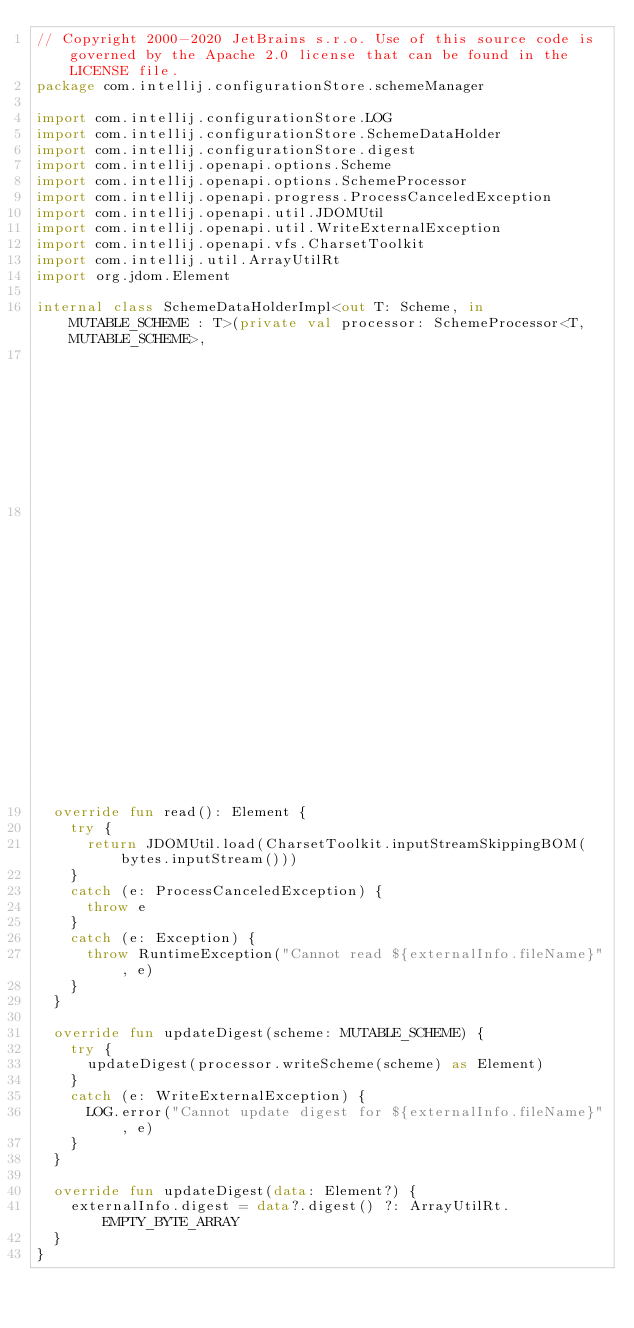Convert code to text. <code><loc_0><loc_0><loc_500><loc_500><_Kotlin_>// Copyright 2000-2020 JetBrains s.r.o. Use of this source code is governed by the Apache 2.0 license that can be found in the LICENSE file.
package com.intellij.configurationStore.schemeManager

import com.intellij.configurationStore.LOG
import com.intellij.configurationStore.SchemeDataHolder
import com.intellij.configurationStore.digest
import com.intellij.openapi.options.Scheme
import com.intellij.openapi.options.SchemeProcessor
import com.intellij.openapi.progress.ProcessCanceledException
import com.intellij.openapi.util.JDOMUtil
import com.intellij.openapi.util.WriteExternalException
import com.intellij.openapi.vfs.CharsetToolkit
import com.intellij.util.ArrayUtilRt
import org.jdom.Element

internal class SchemeDataHolderImpl<out T: Scheme, in MUTABLE_SCHEME : T>(private val processor: SchemeProcessor<T, MUTABLE_SCHEME>,
                                                                          private val bytes: ByteArray,
                                                                          private val externalInfo: ExternalInfo) : SchemeDataHolder<MUTABLE_SCHEME> {
  override fun read(): Element {
    try {
      return JDOMUtil.load(CharsetToolkit.inputStreamSkippingBOM(bytes.inputStream()))
    }
    catch (e: ProcessCanceledException) {
      throw e
    }
    catch (e: Exception) {
      throw RuntimeException("Cannot read ${externalInfo.fileName}", e)
    }
  }

  override fun updateDigest(scheme: MUTABLE_SCHEME) {
    try {
      updateDigest(processor.writeScheme(scheme) as Element)
    }
    catch (e: WriteExternalException) {
      LOG.error("Cannot update digest for ${externalInfo.fileName}", e)
    }
  }

  override fun updateDigest(data: Element?) {
    externalInfo.digest = data?.digest() ?: ArrayUtilRt.EMPTY_BYTE_ARRAY
  }
}</code> 